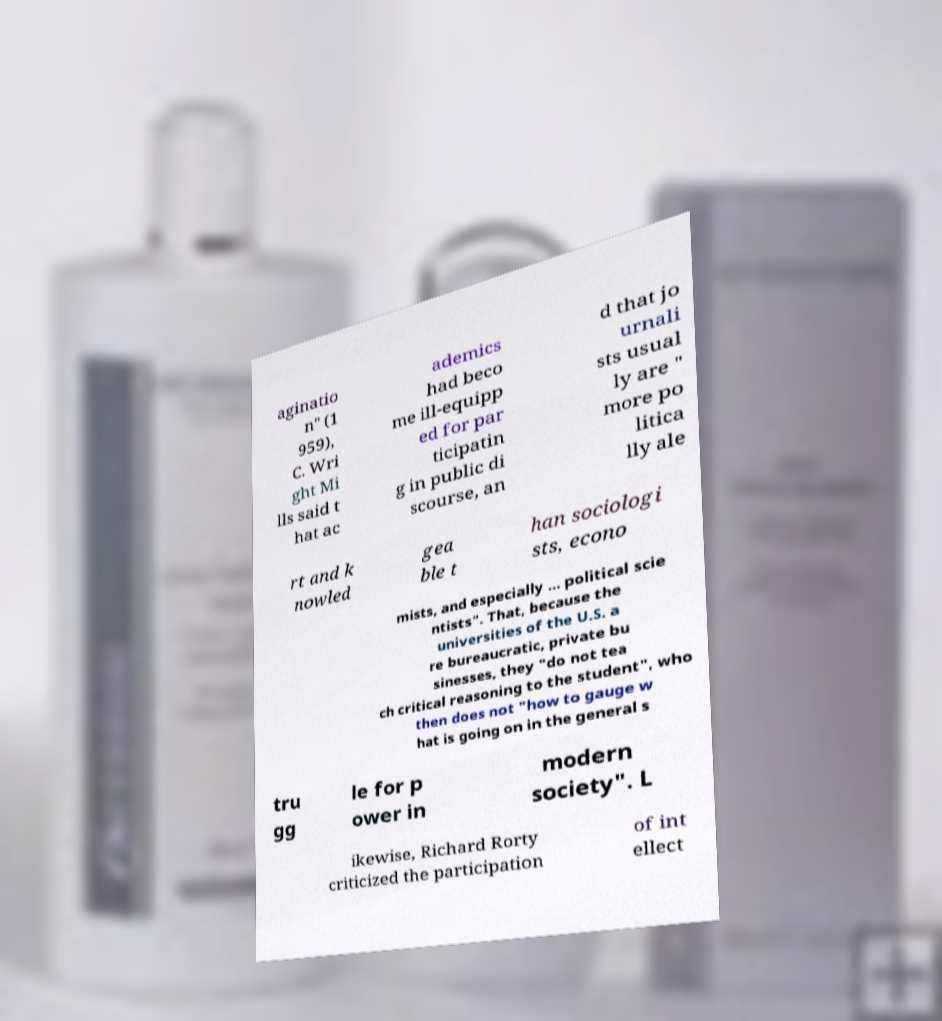What messages or text are displayed in this image? I need them in a readable, typed format. aginatio n" (1 959), C. Wri ght Mi lls said t hat ac ademics had beco me ill-equipp ed for par ticipatin g in public di scourse, an d that jo urnali sts usual ly are " more po litica lly ale rt and k nowled gea ble t han sociologi sts, econo mists, and especially ... political scie ntists". That, because the universities of the U.S. a re bureaucratic, private bu sinesses, they "do not tea ch critical reasoning to the student", who then does not "how to gauge w hat is going on in the general s tru gg le for p ower in modern society". L ikewise, Richard Rorty criticized the participation of int ellect 